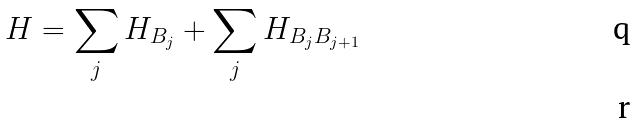Convert formula to latex. <formula><loc_0><loc_0><loc_500><loc_500>H = \sum _ { j } H _ { B _ { j } } + \sum _ { j } H _ { B _ { j } B _ { j + 1 } } \\</formula> 